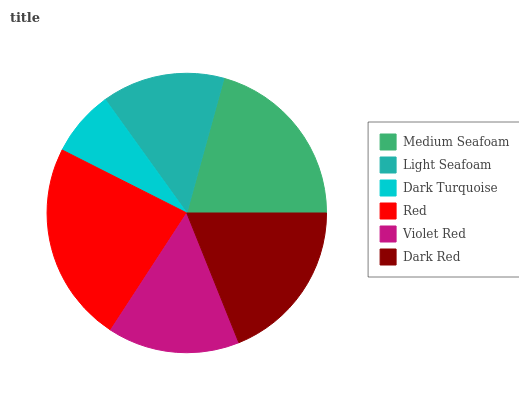Is Dark Turquoise the minimum?
Answer yes or no. Yes. Is Red the maximum?
Answer yes or no. Yes. Is Light Seafoam the minimum?
Answer yes or no. No. Is Light Seafoam the maximum?
Answer yes or no. No. Is Medium Seafoam greater than Light Seafoam?
Answer yes or no. Yes. Is Light Seafoam less than Medium Seafoam?
Answer yes or no. Yes. Is Light Seafoam greater than Medium Seafoam?
Answer yes or no. No. Is Medium Seafoam less than Light Seafoam?
Answer yes or no. No. Is Dark Red the high median?
Answer yes or no. Yes. Is Violet Red the low median?
Answer yes or no. Yes. Is Dark Turquoise the high median?
Answer yes or no. No. Is Light Seafoam the low median?
Answer yes or no. No. 